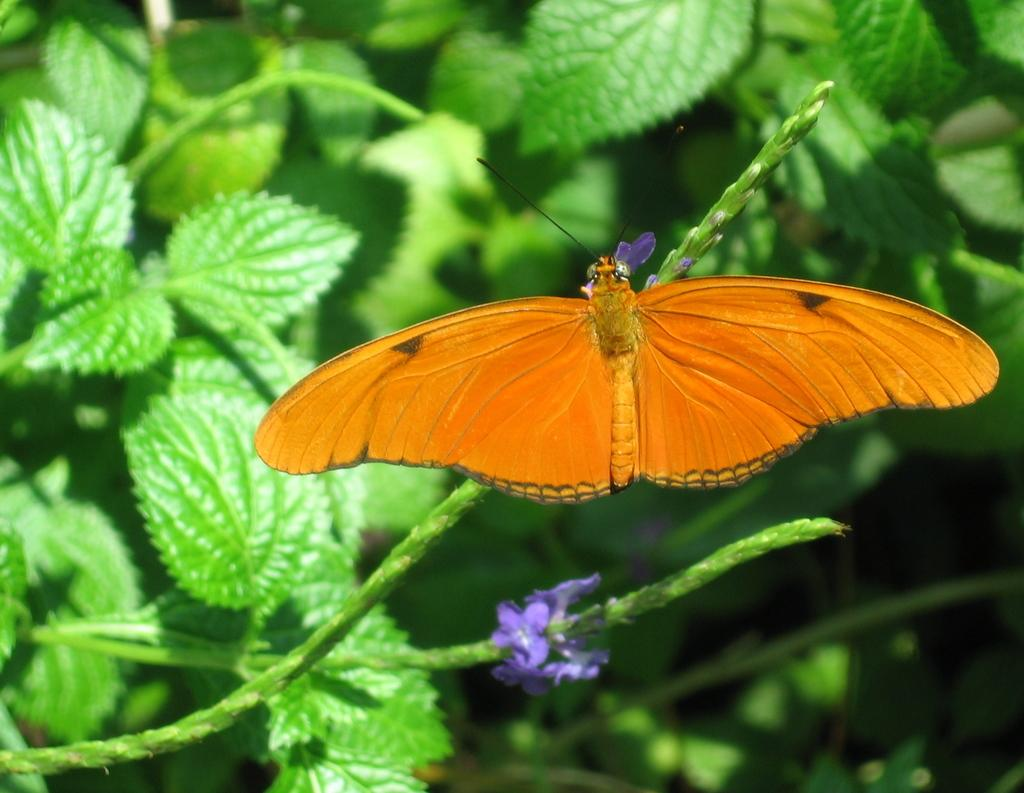What type of animal can be seen in the image? There is a butterfly in the image. What other living organisms are present in the image? There are flowers and plants in the image. Can you describe the plants in the image? The plants in the image are not specified, but they are present alongside the flowers. What type of oatmeal is being served in the image? There is no oatmeal present in the image; it features a butterfly, flowers, and plants. 